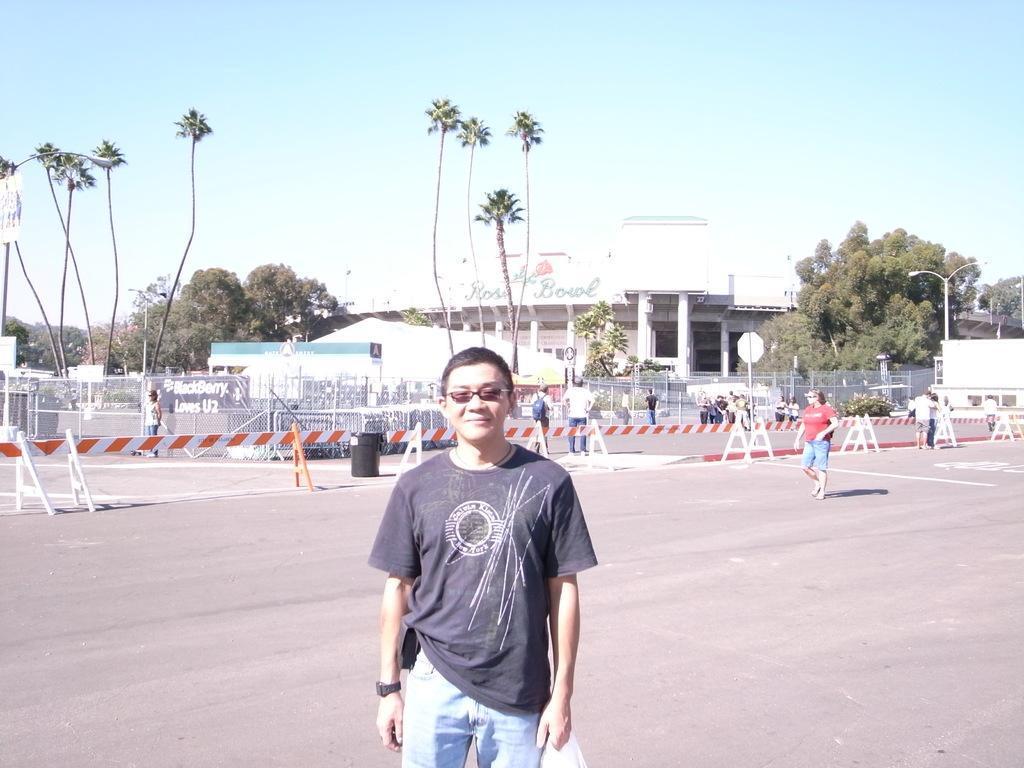How would you summarize this image in a sentence or two? In this picture I can see there is a man standing and he is wearing a T-shirt and glasses, there are a few more people in the backdrop and there is a building in the backdrop, there is a banner, poles with lights and trees. The sky is clear. 